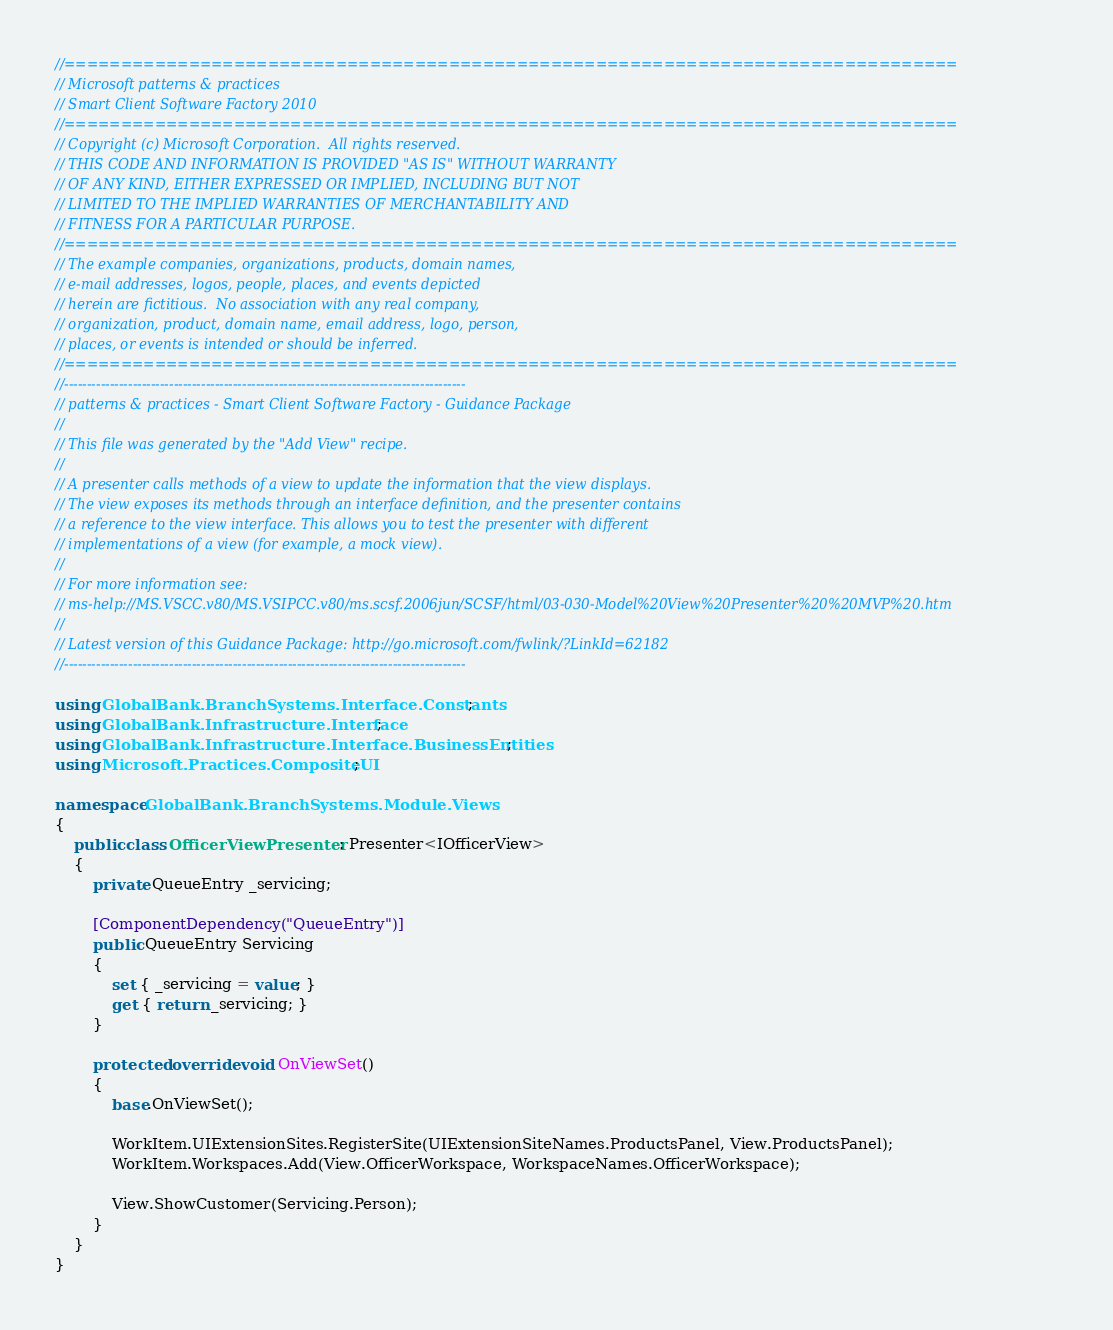<code> <loc_0><loc_0><loc_500><loc_500><_C#_>//===============================================================================
// Microsoft patterns & practices
// Smart Client Software Factory 2010
//===============================================================================
// Copyright (c) Microsoft Corporation.  All rights reserved.
// THIS CODE AND INFORMATION IS PROVIDED "AS IS" WITHOUT WARRANTY
// OF ANY KIND, EITHER EXPRESSED OR IMPLIED, INCLUDING BUT NOT
// LIMITED TO THE IMPLIED WARRANTIES OF MERCHANTABILITY AND
// FITNESS FOR A PARTICULAR PURPOSE.
//===============================================================================
// The example companies, organizations, products, domain names,
// e-mail addresses, logos, people, places, and events depicted
// herein are fictitious.  No association with any real company,
// organization, product, domain name, email address, logo, person,
// places, or events is intended or should be inferred.
//===============================================================================
//----------------------------------------------------------------------------------------
// patterns & practices - Smart Client Software Factory - Guidance Package
//
// This file was generated by the "Add View" recipe.
//
// A presenter calls methods of a view to update the information that the view displays. 
// The view exposes its methods through an interface definition, and the presenter contains
// a reference to the view interface. This allows you to test the presenter with different 
// implementations of a view (for example, a mock view).
//
// For more information see:
// ms-help://MS.VSCC.v80/MS.VSIPCC.v80/ms.scsf.2006jun/SCSF/html/03-030-Model%20View%20Presenter%20%20MVP%20.htm
//
// Latest version of this Guidance Package: http://go.microsoft.com/fwlink/?LinkId=62182
//----------------------------------------------------------------------------------------

using GlobalBank.BranchSystems.Interface.Constants;
using GlobalBank.Infrastructure.Interface;
using GlobalBank.Infrastructure.Interface.BusinessEntities;
using Microsoft.Practices.CompositeUI;

namespace GlobalBank.BranchSystems.Module.Views
{
	public class OfficerViewPresenter : Presenter<IOfficerView>
	{
		private QueueEntry _servicing;

		[ComponentDependency("QueueEntry")]
		public QueueEntry Servicing
		{
			set { _servicing = value; }
			get { return _servicing; }
		}

		protected override void OnViewSet()
		{
			base.OnViewSet();

			WorkItem.UIExtensionSites.RegisterSite(UIExtensionSiteNames.ProductsPanel, View.ProductsPanel);
			WorkItem.Workspaces.Add(View.OfficerWorkspace, WorkspaceNames.OfficerWorkspace);

			View.ShowCustomer(Servicing.Person);
		}
	}
}
</code> 